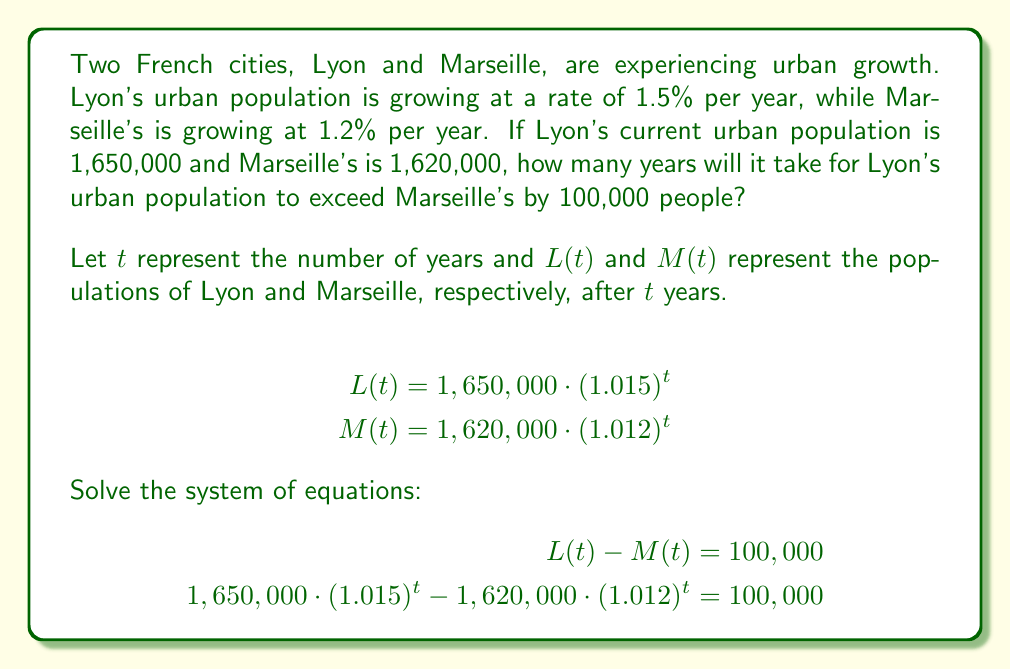Could you help me with this problem? To solve this problem, we need to use the compound interest formula and set up a system of equations:

1) First, let's write out the equations for the populations of Lyon and Marseille after $t$ years:

   Lyon: $L(t) = 1,650,000 \cdot (1.015)^t$
   Marseille: $M(t) = 1,620,000 \cdot (1.012)^t$

2) We want to find when the difference between these populations is 100,000:

   $L(t) - M(t) = 100,000$

3) Substituting the equations from step 1:

   $1,650,000 \cdot (1.015)^t - 1,620,000 \cdot (1.012)^t = 100,000$

4) This equation can't be solved algebraically, so we need to use a numerical method like goal seek or trial and error.

5) Let's try some values:

   For $t = 10$:
   $1,650,000 \cdot (1.015)^{10} - 1,620,000 \cdot (1.012)^{10} \approx 91,615$

   For $t = 11$:
   $1,650,000 \cdot (1.015)^{11} - 1,620,000 \cdot (1.012)^{11} \approx 102,920$

6) We can see that the difference exceeds 100,000 sometime between 10 and 11 years.

7) Using a more precise numerical method or calculator with goal seek function, we can find that the exact value is approximately 10.8 years.

8) Since we're asked for the number of whole years, we round up to 11 years.
Answer: It will take 11 years for Lyon's urban population to exceed Marseille's by 100,000 people. 